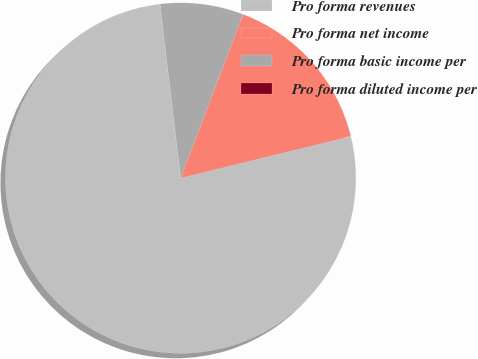<chart> <loc_0><loc_0><loc_500><loc_500><pie_chart><fcel>Pro forma revenues<fcel>Pro forma net income<fcel>Pro forma basic income per<fcel>Pro forma diluted income per<nl><fcel>76.92%<fcel>15.38%<fcel>7.69%<fcel>0.0%<nl></chart> 